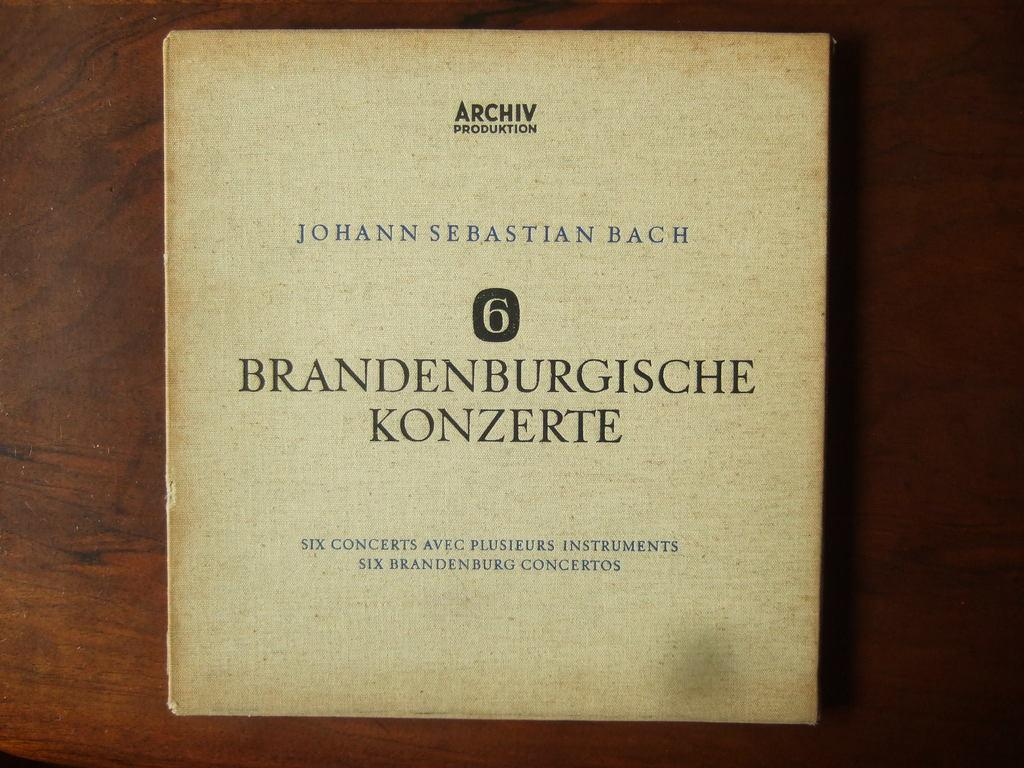What object can be seen in the image? There is a book in the image. Where is the book located? The book is placed on a table. What type of comb is used to read the book in the image? There is no comb present in the image, and the book is not being read with a comb. 